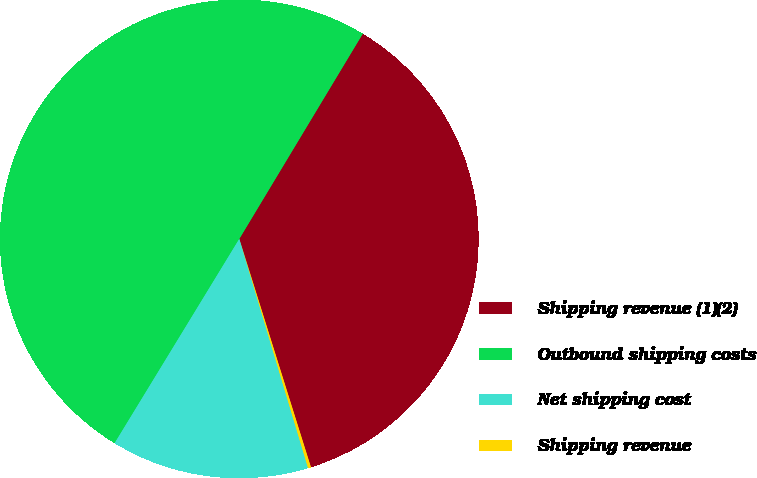Convert chart. <chart><loc_0><loc_0><loc_500><loc_500><pie_chart><fcel>Shipping revenue (1)(2)<fcel>Outbound shipping costs<fcel>Net shipping cost<fcel>Shipping revenue<nl><fcel>36.54%<fcel>49.9%<fcel>13.36%<fcel>0.2%<nl></chart> 